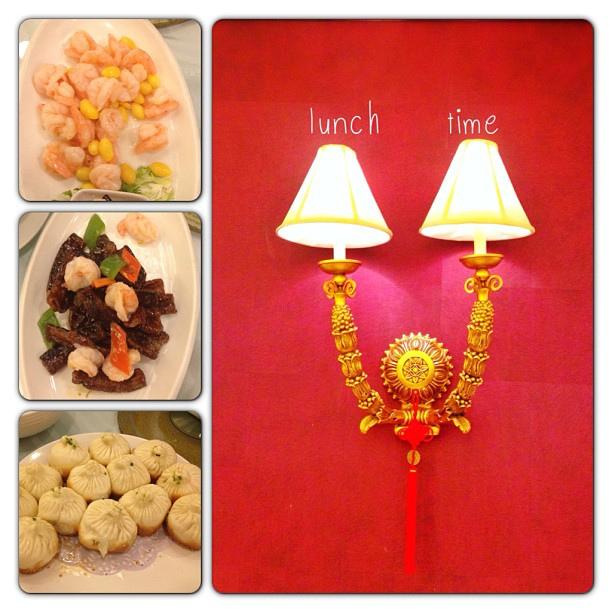What food is on the top left?
Quick response, please. Shrimp. Is this a table lamp?
Write a very short answer. No. What color are the peppers?
Short answer required. Green. What kind of display this?
Be succinct. Food. 